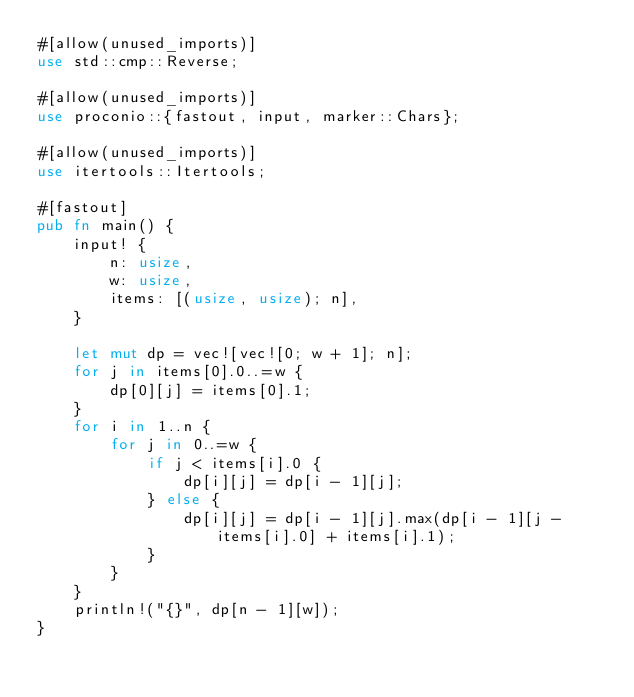<code> <loc_0><loc_0><loc_500><loc_500><_Rust_>#[allow(unused_imports)]
use std::cmp::Reverse;

#[allow(unused_imports)]
use proconio::{fastout, input, marker::Chars};

#[allow(unused_imports)]
use itertools::Itertools;

#[fastout]
pub fn main() {
    input! {
        n: usize,
        w: usize,
        items: [(usize, usize); n],
    }

    let mut dp = vec![vec![0; w + 1]; n];
    for j in items[0].0..=w {
        dp[0][j] = items[0].1;
    }
    for i in 1..n {
        for j in 0..=w {
            if j < items[i].0 {
                dp[i][j] = dp[i - 1][j];
            } else {
                dp[i][j] = dp[i - 1][j].max(dp[i - 1][j - items[i].0] + items[i].1);
            }
        }
    }
    println!("{}", dp[n - 1][w]);
}
</code> 